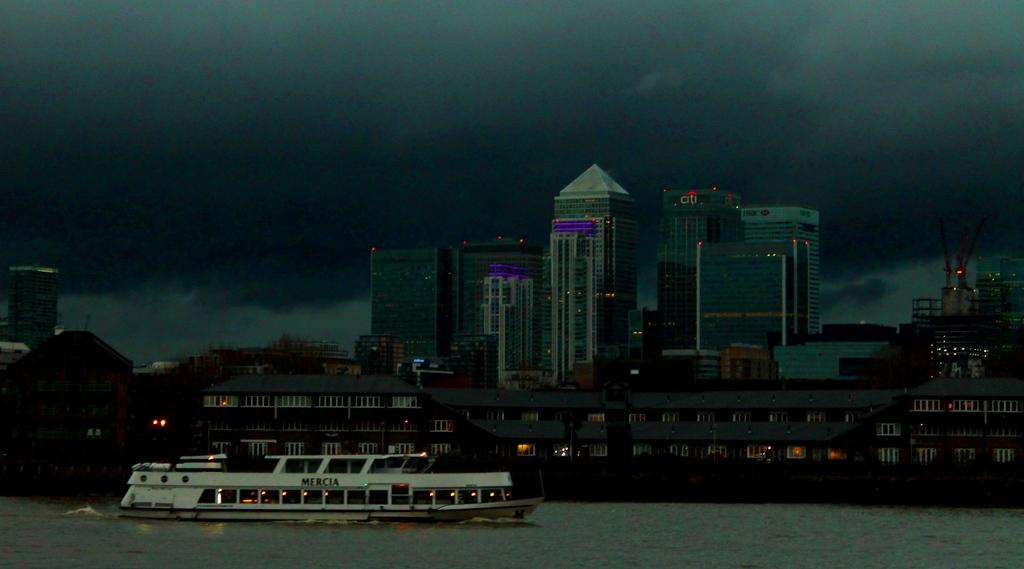Provide a one-sentence caption for the provided image. A boat with Mercia on it in front of a city skyline. 